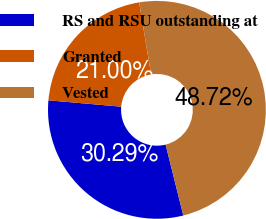Convert chart to OTSL. <chart><loc_0><loc_0><loc_500><loc_500><pie_chart><fcel>RS and RSU outstanding at<fcel>Granted<fcel>Vested<nl><fcel>30.29%<fcel>21.0%<fcel>48.72%<nl></chart> 